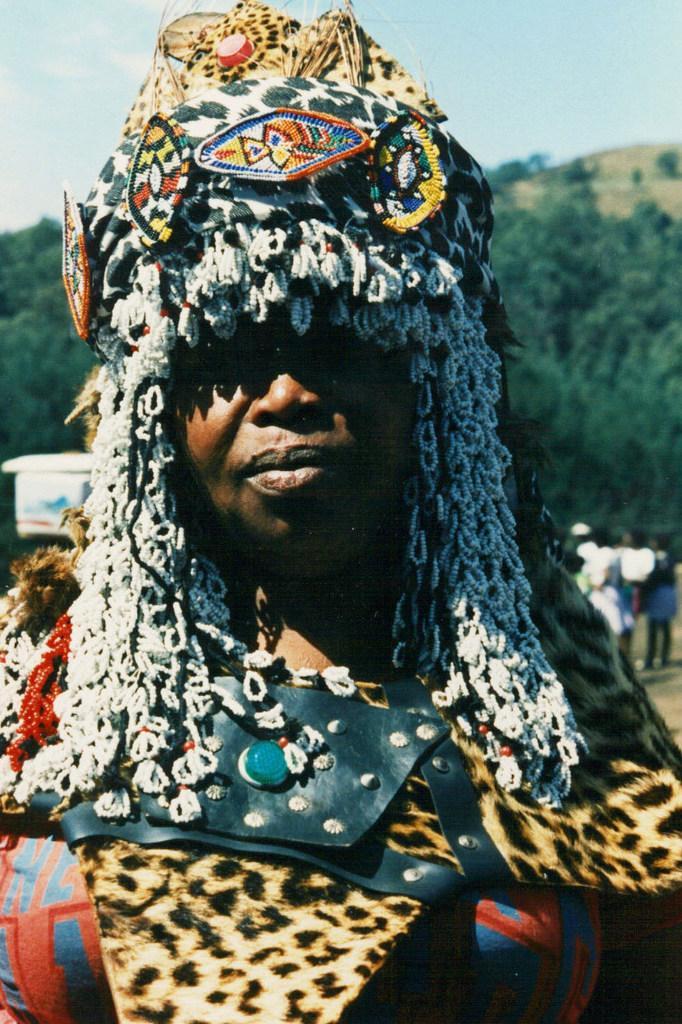Can you describe this image briefly? In this picture we can see a woman, she is wearing a costume and in the background we can see people, trees, sky and some objects. 